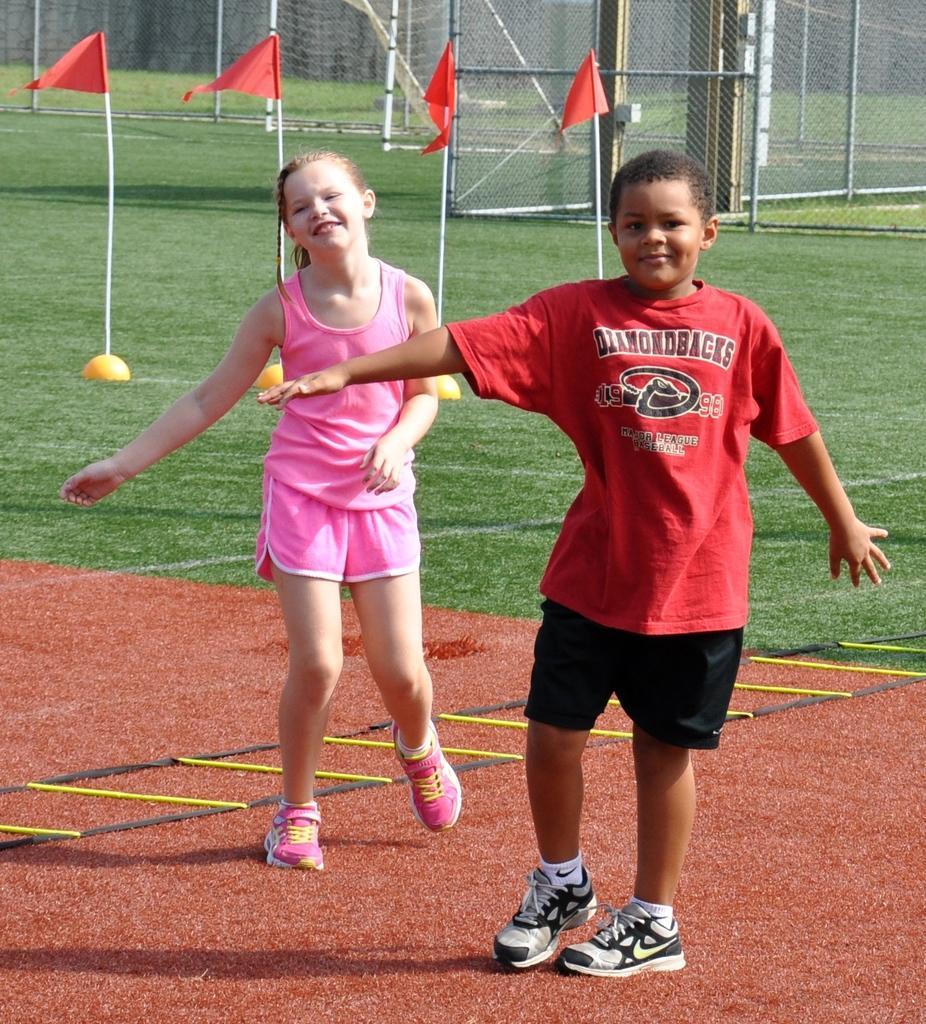Can you describe this image briefly? In the center of the image we can see a girl and a boy are there. At the top of the image we can see some meshes, flags, poles are there. At the bottom of the image ground is there. 